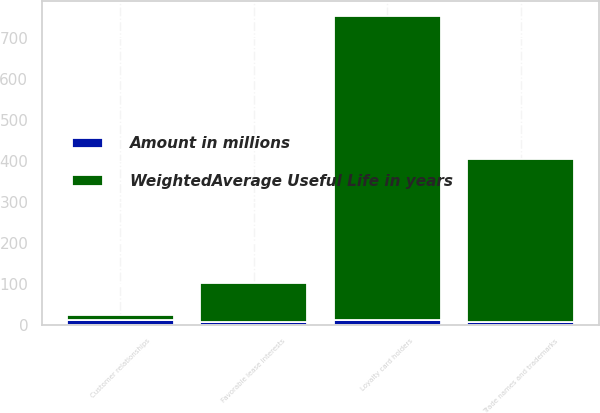<chart> <loc_0><loc_0><loc_500><loc_500><stacked_bar_chart><ecel><fcel>Customer relationships<fcel>Loyalty card holders<fcel>Trade names and trademarks<fcel>Favorable lease interests<nl><fcel>Amount in millions<fcel>12<fcel>12<fcel>7<fcel>8<nl><fcel>WeightedAverage Useful Life in years<fcel>12<fcel>742<fcel>399<fcel>93<nl></chart> 